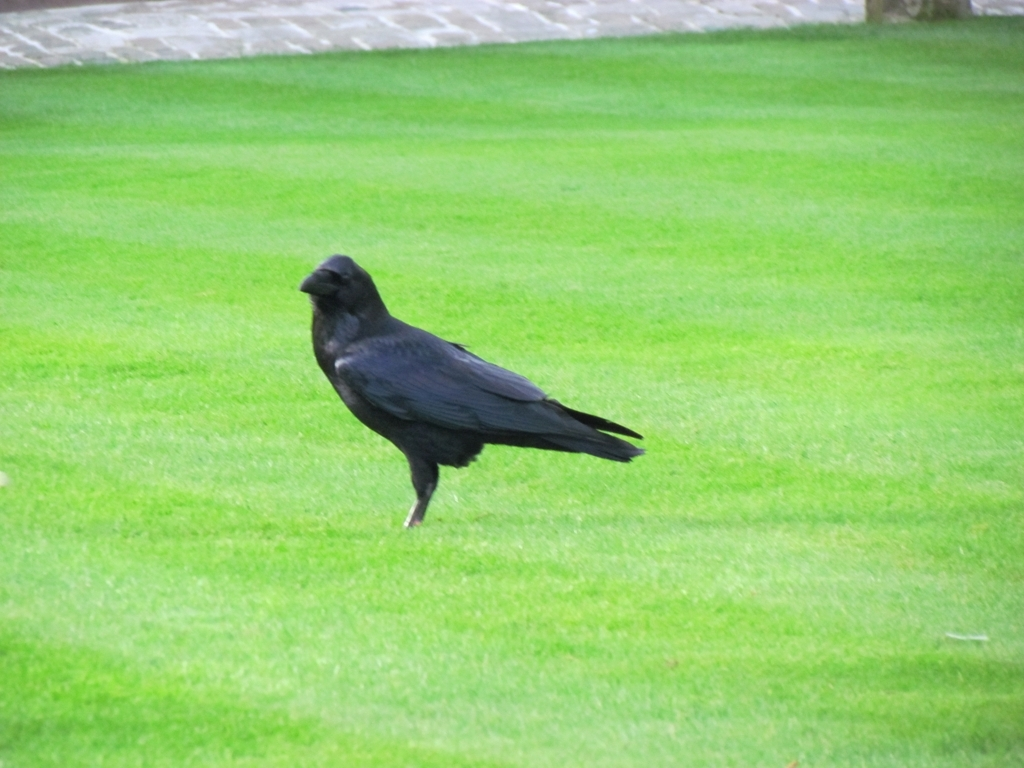Is there any cultural significance associated with crows that can be tied to this image? Crows are often depicted in various cultural myths and folklore, symbolizing intelligence, adaptability, and sometimes mystery or the unknown. This image of a crow calmly perched on the grass could evoke those themes, leaving viewers to ponder the stories and symbolism that these birds carry with them. What could the setting of this image suggest about the location? The setting, featuring well-maintained grass and what seems like a stone structure in the background, might suggest a park or a similar public space, possibly in an area with a temperate climate due to the lush, green grass. 